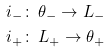<formula> <loc_0><loc_0><loc_500><loc_500>i _ { - } & \colon \, \theta _ { - } \rightarrow L _ { - } \\ i _ { + } & \colon \, L _ { + } \rightarrow \theta _ { + }</formula> 